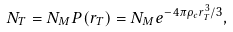Convert formula to latex. <formula><loc_0><loc_0><loc_500><loc_500>N _ { T } = N _ { M } P ( r _ { T } ) = N _ { M } e ^ { - 4 \pi \rho _ { c } r _ { T } ^ { 3 } / 3 } ,</formula> 